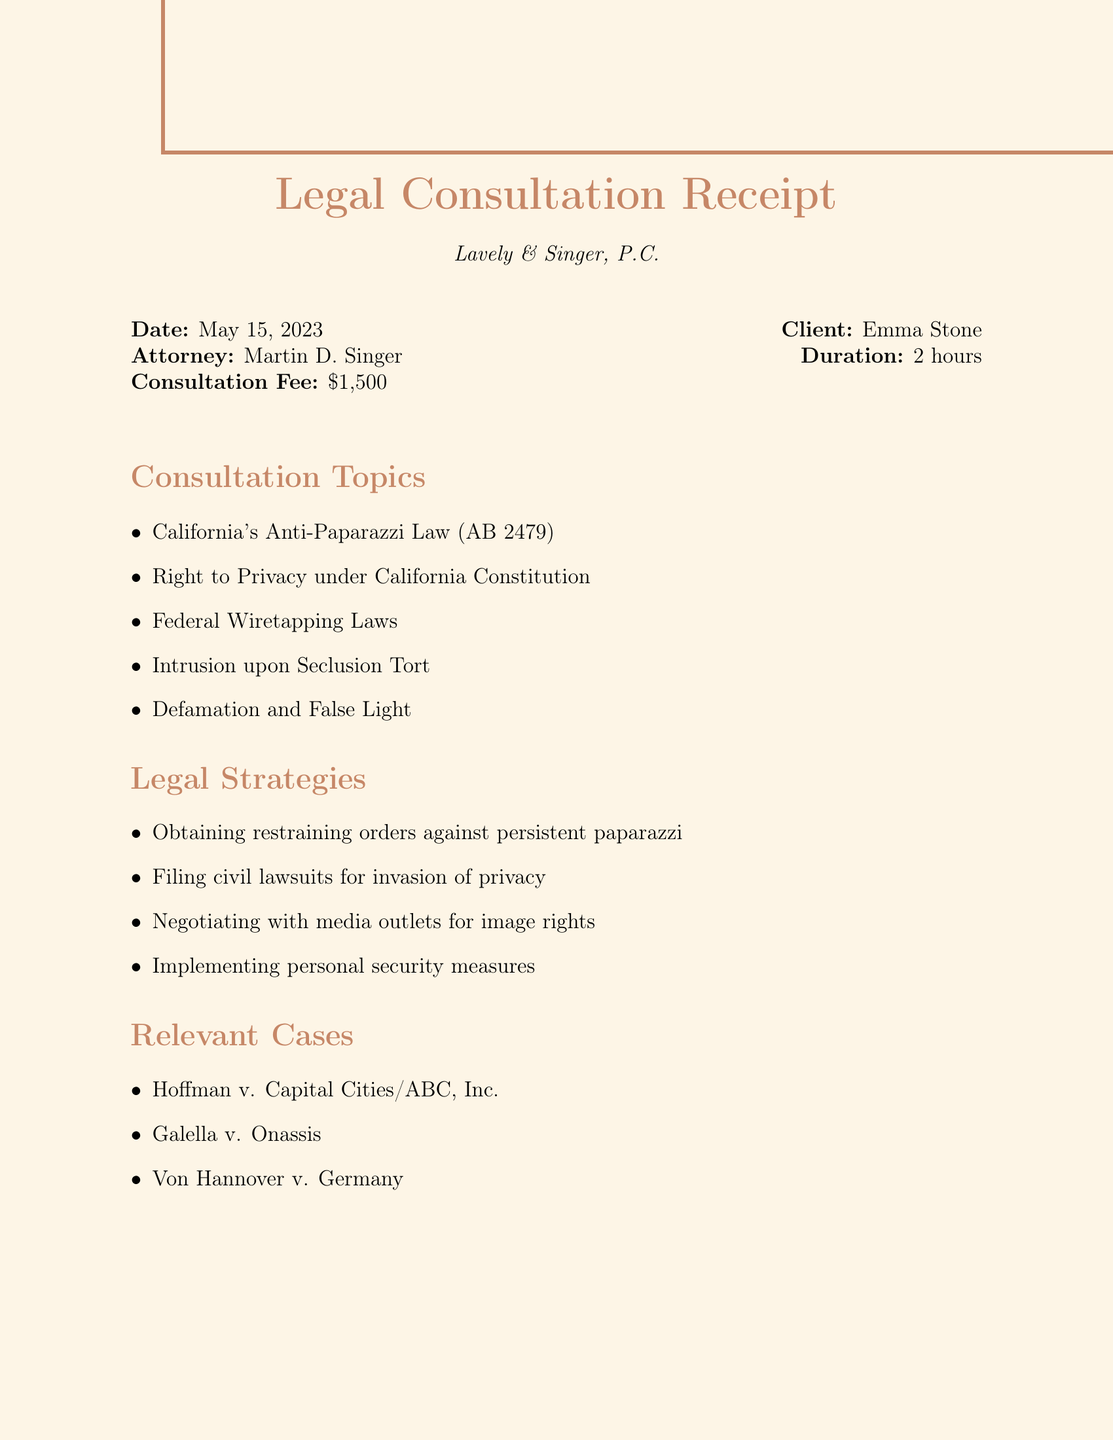What is the date of the consultation? The date of the consultation is specified in the document as May 15, 2023.
Answer: May 15, 2023 Who is the attorney mentioned in the document? The attorney's name is listed as Martin D. Singer.
Answer: Martin D. Singer What is the consultation fee? The consultation fee is clearly stated in the document as $1,500.
Answer: $1,500 Which section covers strategies for dealing with paparazzi? The document has a section titled "Legal Strategies" that outlines various strategies.
Answer: Legal Strategies What is the retainer fee for on-call legal support? The retainer fee for on-call legal support is mentioned as $5,000.
Answer: $5,000 How long did the consultation last? The duration of the consultation is noted as 2 hours in the document.
Answer: 2 hours What legal topic addresses specific privacy rights in California? The document references "Right to Privacy under California Constitution" as a relevant topic.
Answer: Right to Privacy under California Constitution Which law firm provided the legal consultation? The law firm providing the consultation is identified as Lavely & Singer, P.C.
Answer: Lavely & Singer, P.C What might be a recommended action to manage media coverage? The document suggests consulting with a personal publicist for media management as a recommended action.
Answer: Consult with a personal publicist for media management 